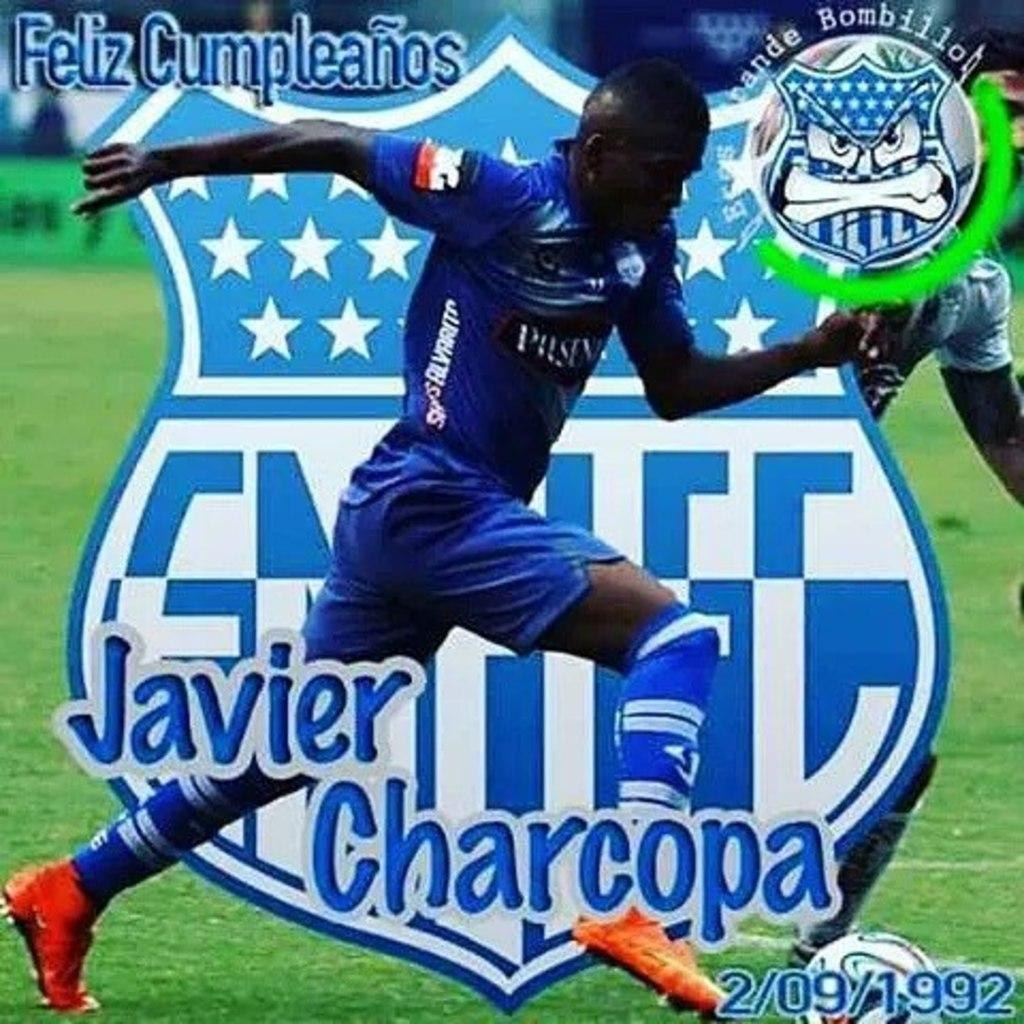<image>
Give a short and clear explanation of the subsequent image. a javier charcopa soccer player graphic colorful display 